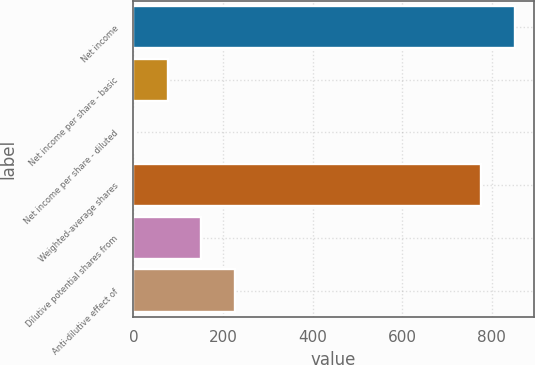<chart> <loc_0><loc_0><loc_500><loc_500><bar_chart><fcel>Net income<fcel>Net income per share - basic<fcel>Net income per share - diluted<fcel>Weighted-average shares<fcel>Dilutive potential shares from<fcel>Anti-dilutive effect of<nl><fcel>851.78<fcel>76.45<fcel>1.06<fcel>776.39<fcel>151.84<fcel>227.23<nl></chart> 